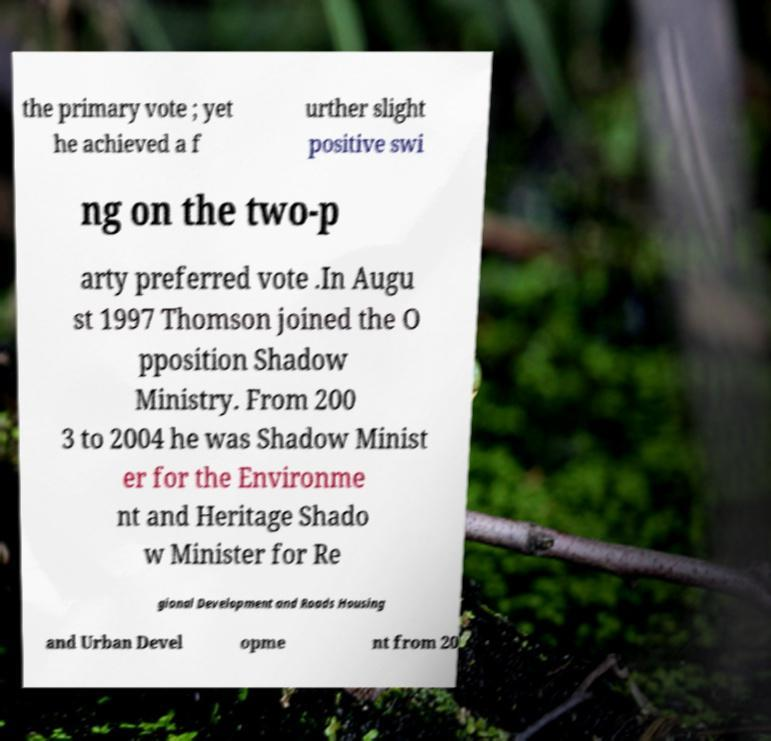What messages or text are displayed in this image? I need them in a readable, typed format. the primary vote ; yet he achieved a f urther slight positive swi ng on the two-p arty preferred vote .In Augu st 1997 Thomson joined the O pposition Shadow Ministry. From 200 3 to 2004 he was Shadow Minist er for the Environme nt and Heritage Shado w Minister for Re gional Development and Roads Housing and Urban Devel opme nt from 20 